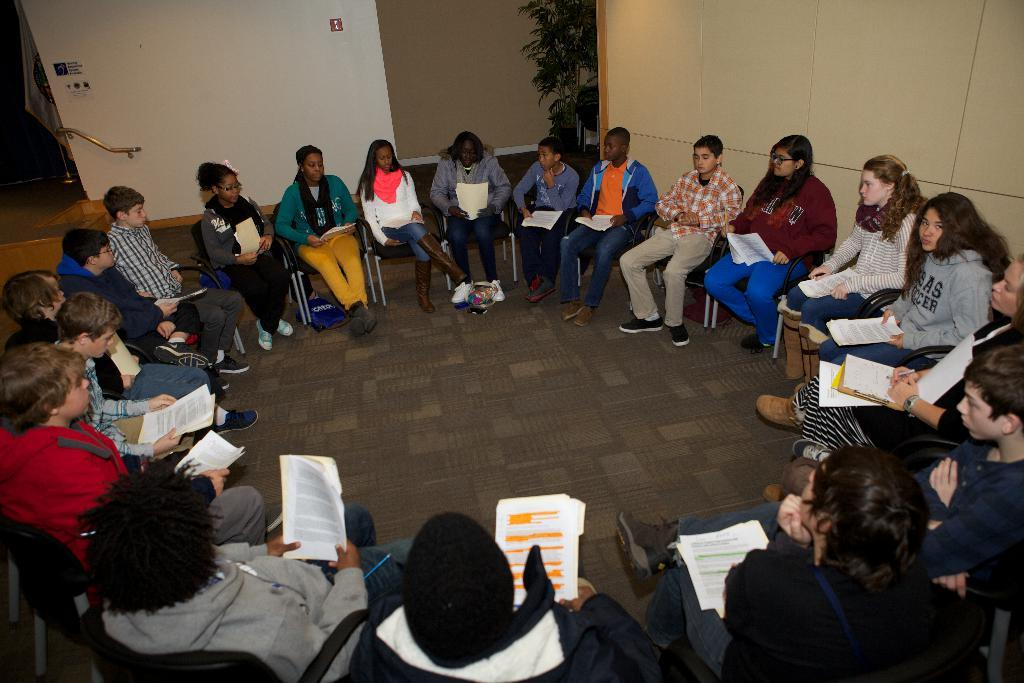What is happening in the image? There is a group of people in the image, and they are sitting on chairs. What are the people holding in their hands? The people are holding papers in their hands. What can be seen in the background of the image? There is a plant and a wall in the background of the image. Can you describe the plant in the image? The plant is green. How would you describe the wall in the background? The wall has both white and brown colors. What type of cloth is draped over the lunchroom table in the image? There is no lunchroom table or cloth present in the image. 